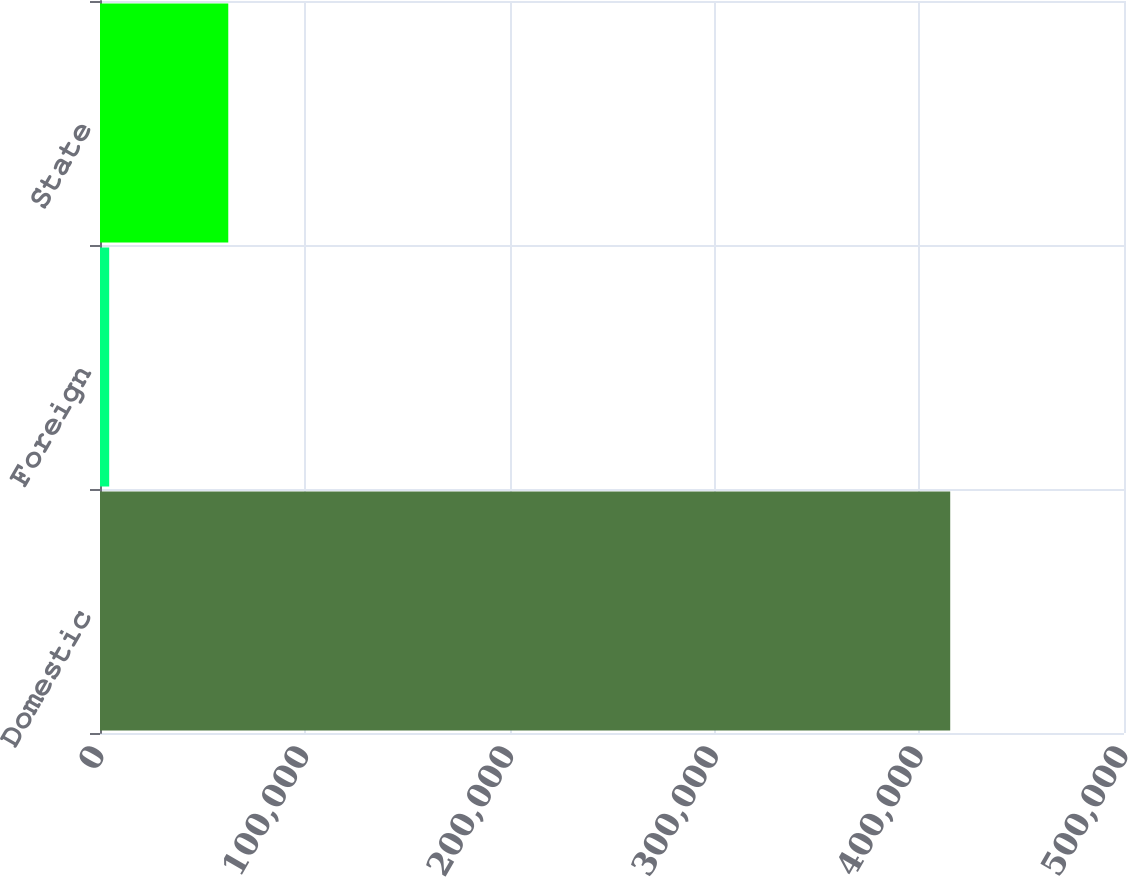Convert chart to OTSL. <chart><loc_0><loc_0><loc_500><loc_500><bar_chart><fcel>Domestic<fcel>Foreign<fcel>State<nl><fcel>415144<fcel>4495<fcel>62630<nl></chart> 